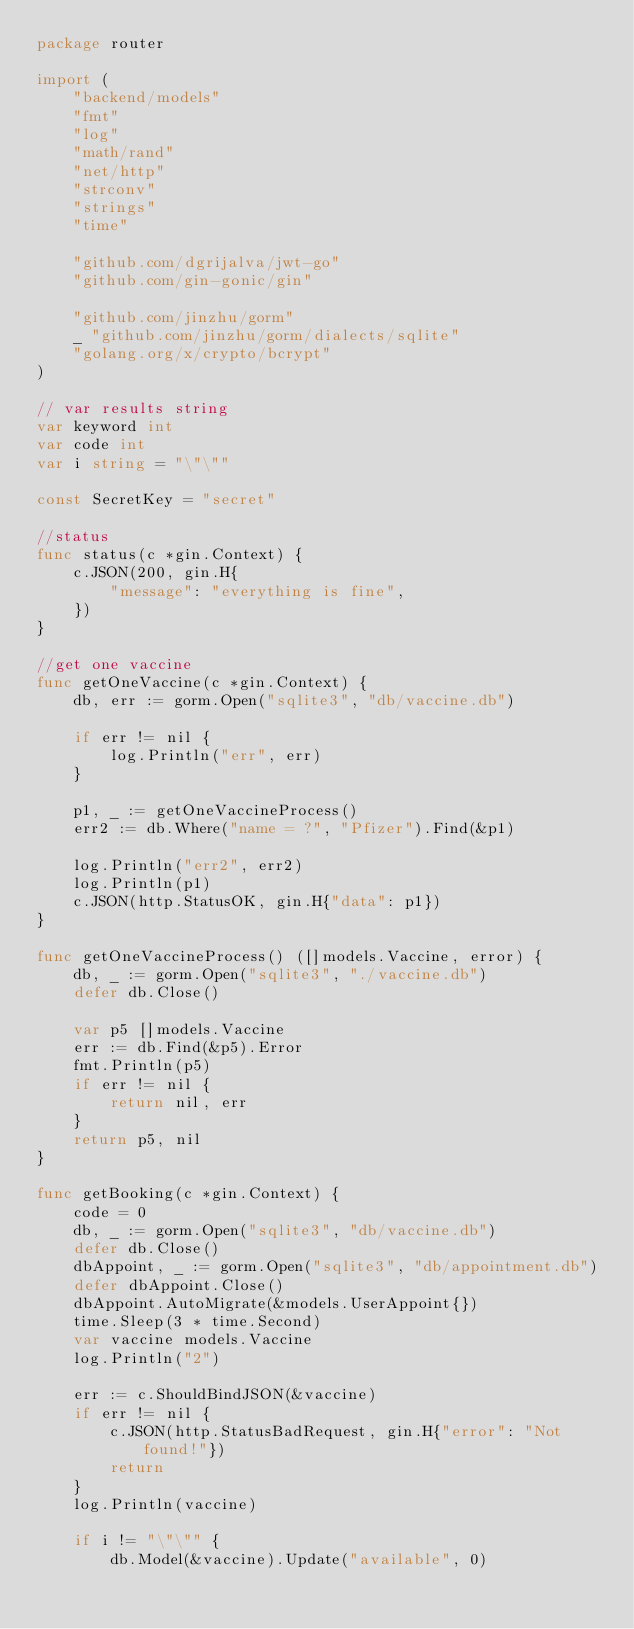<code> <loc_0><loc_0><loc_500><loc_500><_Go_>package router

import (
	"backend/models"
	"fmt"
	"log"
	"math/rand"
	"net/http"
	"strconv"
	"strings"
	"time"

	"github.com/dgrijalva/jwt-go"
	"github.com/gin-gonic/gin"

	"github.com/jinzhu/gorm"
	_ "github.com/jinzhu/gorm/dialects/sqlite"
	"golang.org/x/crypto/bcrypt"
)

// var results string
var keyword int
var code int
var i string = "\"\""

const SecretKey = "secret"

//status
func status(c *gin.Context) {
	c.JSON(200, gin.H{
		"message": "everything is fine",
	})
}

//get one vaccine
func getOneVaccine(c *gin.Context) {
	db, err := gorm.Open("sqlite3", "db/vaccine.db")

	if err != nil {
		log.Println("err", err)
	}

	p1, _ := getOneVaccineProcess()
	err2 := db.Where("name = ?", "Pfizer").Find(&p1)

	log.Println("err2", err2)
	log.Println(p1)
	c.JSON(http.StatusOK, gin.H{"data": p1})
}

func getOneVaccineProcess() ([]models.Vaccine, error) {
	db, _ := gorm.Open("sqlite3", "./vaccine.db")
	defer db.Close()

	var p5 []models.Vaccine
	err := db.Find(&p5).Error
	fmt.Println(p5)
	if err != nil {
		return nil, err
	}
	return p5, nil
}

func getBooking(c *gin.Context) {
	code = 0
	db, _ := gorm.Open("sqlite3", "db/vaccine.db")
	defer db.Close()
	dbAppoint, _ := gorm.Open("sqlite3", "db/appointment.db")
	defer dbAppoint.Close()
	dbAppoint.AutoMigrate(&models.UserAppoint{})
	time.Sleep(3 * time.Second)
	var vaccine models.Vaccine
	log.Println("2")

	err := c.ShouldBindJSON(&vaccine)
	if err != nil {
		c.JSON(http.StatusBadRequest, gin.H{"error": "Not found!"})
		return
	}
	log.Println(vaccine)

	if i != "\"\"" {
		db.Model(&vaccine).Update("available", 0)</code> 